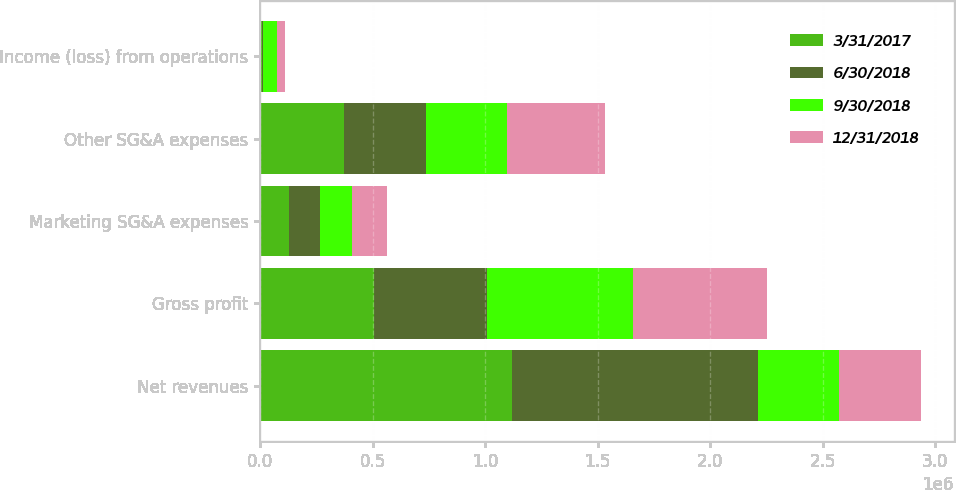Convert chart. <chart><loc_0><loc_0><loc_500><loc_500><stacked_bar_chart><ecel><fcel>Net revenues<fcel>Gross profit<fcel>Marketing SG&A expenses<fcel>Other SG&A expenses<fcel>Income (loss) from operations<nl><fcel>3/31/2017<fcel>1.11984e+06<fcel>507937<fcel>128336<fcel>372064<fcel>7536<nl><fcel>6/30/2018<fcel>1.09119e+06<fcel>501193<fcel>136071<fcel>366809<fcel>4785<nl><fcel>9/30/2018<fcel>362219<fcel>648726<fcel>143919<fcel>357629<fcel>62180<nl><fcel>12/31/2018<fcel>362219<fcel>593558<fcel>156800<fcel>437894<fcel>37088<nl></chart> 